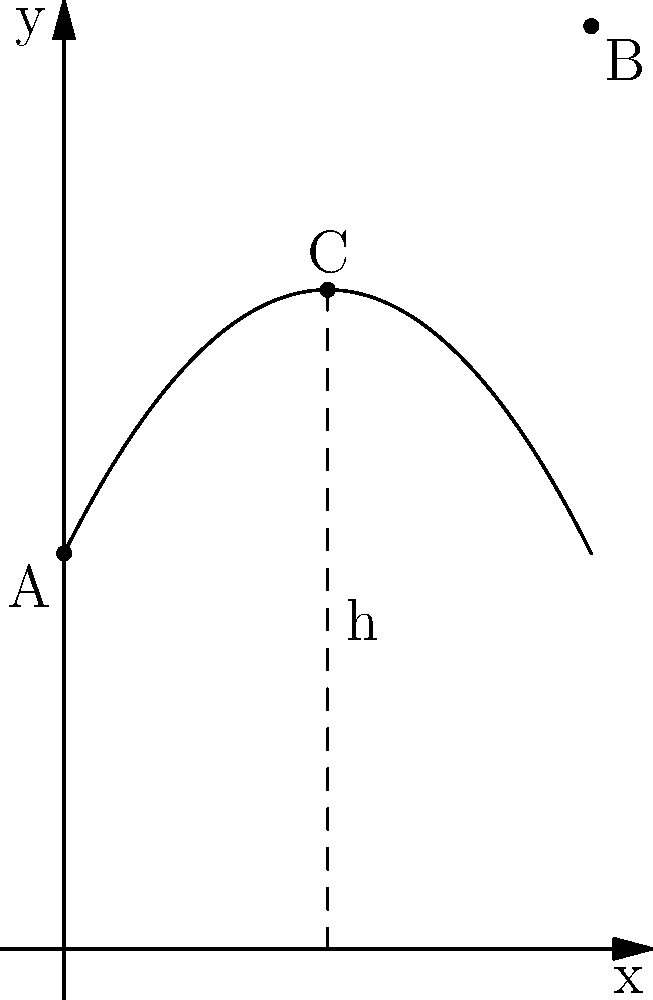In a modern horror story, a witch casts a spell that sends a cursed object flying through the air. The trajectory of the object follows a parabolic path resembling the shape of a witch's hat, described by the function $f(x) = -0.5x^2 + 2x + 3$, where $x$ is the horizontal distance and $f(x)$ is the height, both measured in meters. Find the maximum height reached by the cursed object. To find the maximum height of the projectile, we need to follow these steps:

1) The maximum height occurs at the vertex of the parabola. For a quadratic function in the form $f(x) = ax^2 + bx + c$, the x-coordinate of the vertex is given by $x = -\frac{b}{2a}$.

2) In our function $f(x) = -0.5x^2 + 2x + 3$, we have:
   $a = -0.5$
   $b = 2$
   $c = 3$

3) Calculating the x-coordinate of the vertex:
   $x = -\frac{b}{2a} = -\frac{2}{2(-0.5)} = -\frac{2}{-1} = 2$

4) To find the maximum height, we need to calculate $f(2)$:
   $f(2) = -0.5(2)^2 + 2(2) + 3$
         $= -0.5(4) + 4 + 3$
         $= -2 + 4 + 3$
         $= 5$

Therefore, the maximum height reached by the cursed object is 5 meters.
Answer: 5 meters 